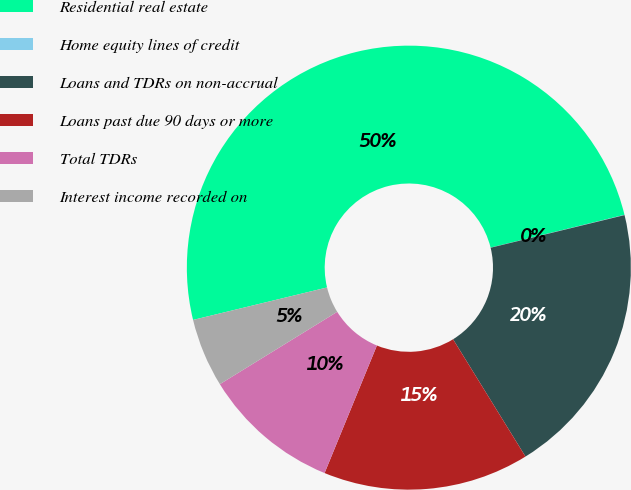<chart> <loc_0><loc_0><loc_500><loc_500><pie_chart><fcel>Residential real estate<fcel>Home equity lines of credit<fcel>Loans and TDRs on non-accrual<fcel>Loans past due 90 days or more<fcel>Total TDRs<fcel>Interest income recorded on<nl><fcel>49.96%<fcel>0.02%<fcel>20.0%<fcel>15.0%<fcel>10.01%<fcel>5.01%<nl></chart> 